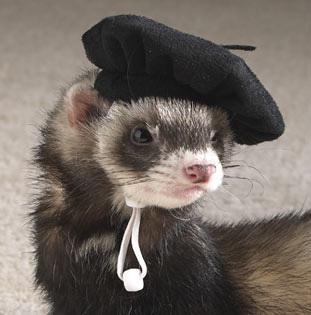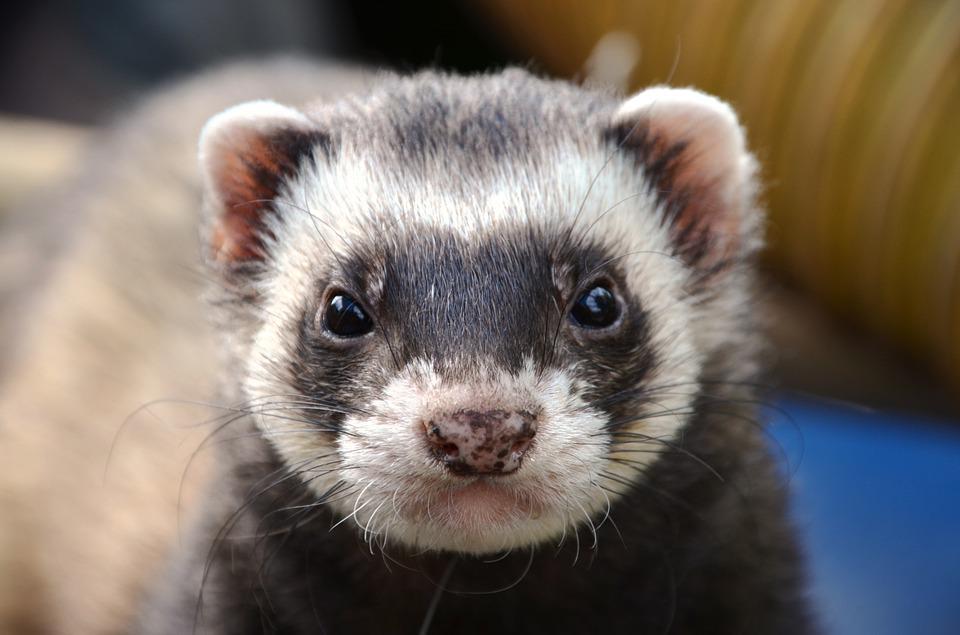The first image is the image on the left, the second image is the image on the right. Given the left and right images, does the statement "at least one animal has its mouth open" hold true? Answer yes or no. No. 